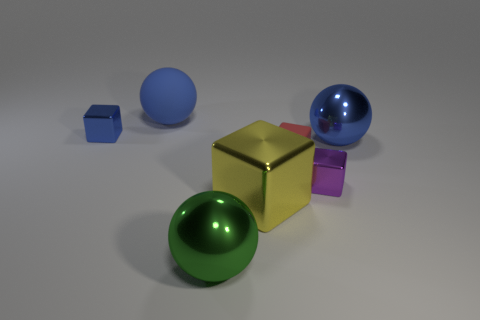Add 3 large blue metal cylinders. How many objects exist? 10 Subtract all blocks. How many objects are left? 3 Add 6 tiny shiny blocks. How many tiny shiny blocks exist? 8 Subtract 0 blue cylinders. How many objects are left? 7 Subtract all yellow matte balls. Subtract all big rubber objects. How many objects are left? 6 Add 1 blue metallic blocks. How many blue metallic blocks are left? 2 